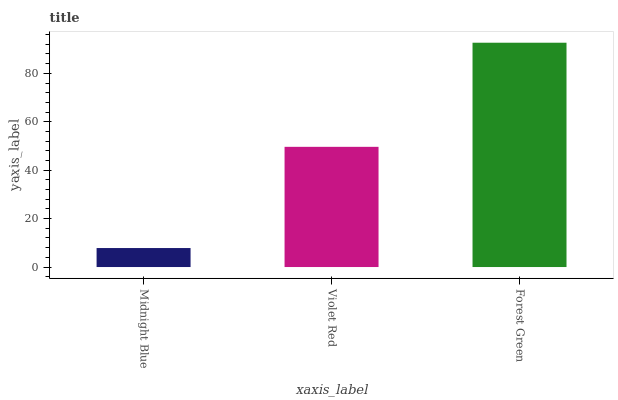Is Midnight Blue the minimum?
Answer yes or no. Yes. Is Forest Green the maximum?
Answer yes or no. Yes. Is Violet Red the minimum?
Answer yes or no. No. Is Violet Red the maximum?
Answer yes or no. No. Is Violet Red greater than Midnight Blue?
Answer yes or no. Yes. Is Midnight Blue less than Violet Red?
Answer yes or no. Yes. Is Midnight Blue greater than Violet Red?
Answer yes or no. No. Is Violet Red less than Midnight Blue?
Answer yes or no. No. Is Violet Red the high median?
Answer yes or no. Yes. Is Violet Red the low median?
Answer yes or no. Yes. Is Midnight Blue the high median?
Answer yes or no. No. Is Forest Green the low median?
Answer yes or no. No. 